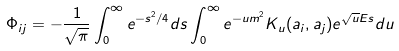<formula> <loc_0><loc_0><loc_500><loc_500>\Phi _ { i j } = - \frac { 1 } { \sqrt { \pi } } \int _ { 0 } ^ { \infty } e ^ { - s ^ { 2 } / 4 } d s \int _ { 0 } ^ { \infty } e ^ { - u m ^ { 2 } } K _ { u } ( a _ { i } , a _ { j } ) e ^ { \sqrt { u } E s } d u</formula> 